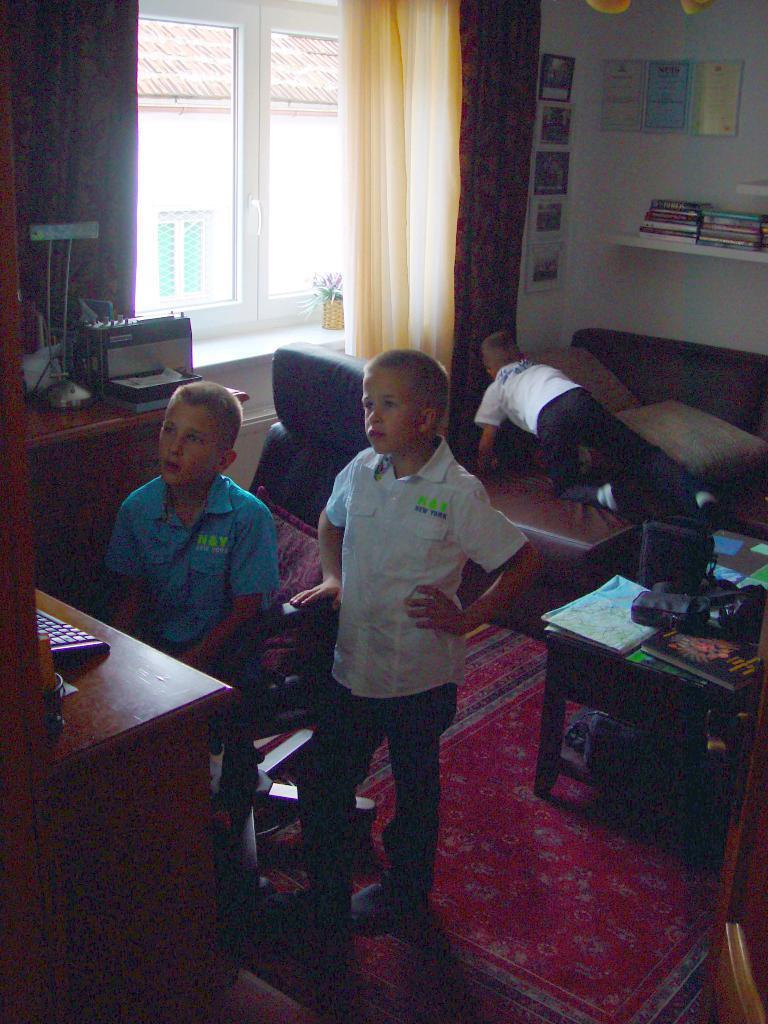Can you describe this image briefly? In this image I see 3 boys, in which one of them is sitting on a chair and another one is standing on a red colored carpet and another one is on a couch which is of brown in color. I see there is a window over here and a wall of white in color and there are racks on which there are lots of books. I see a table which is of brown in color and there are things kept on it. 